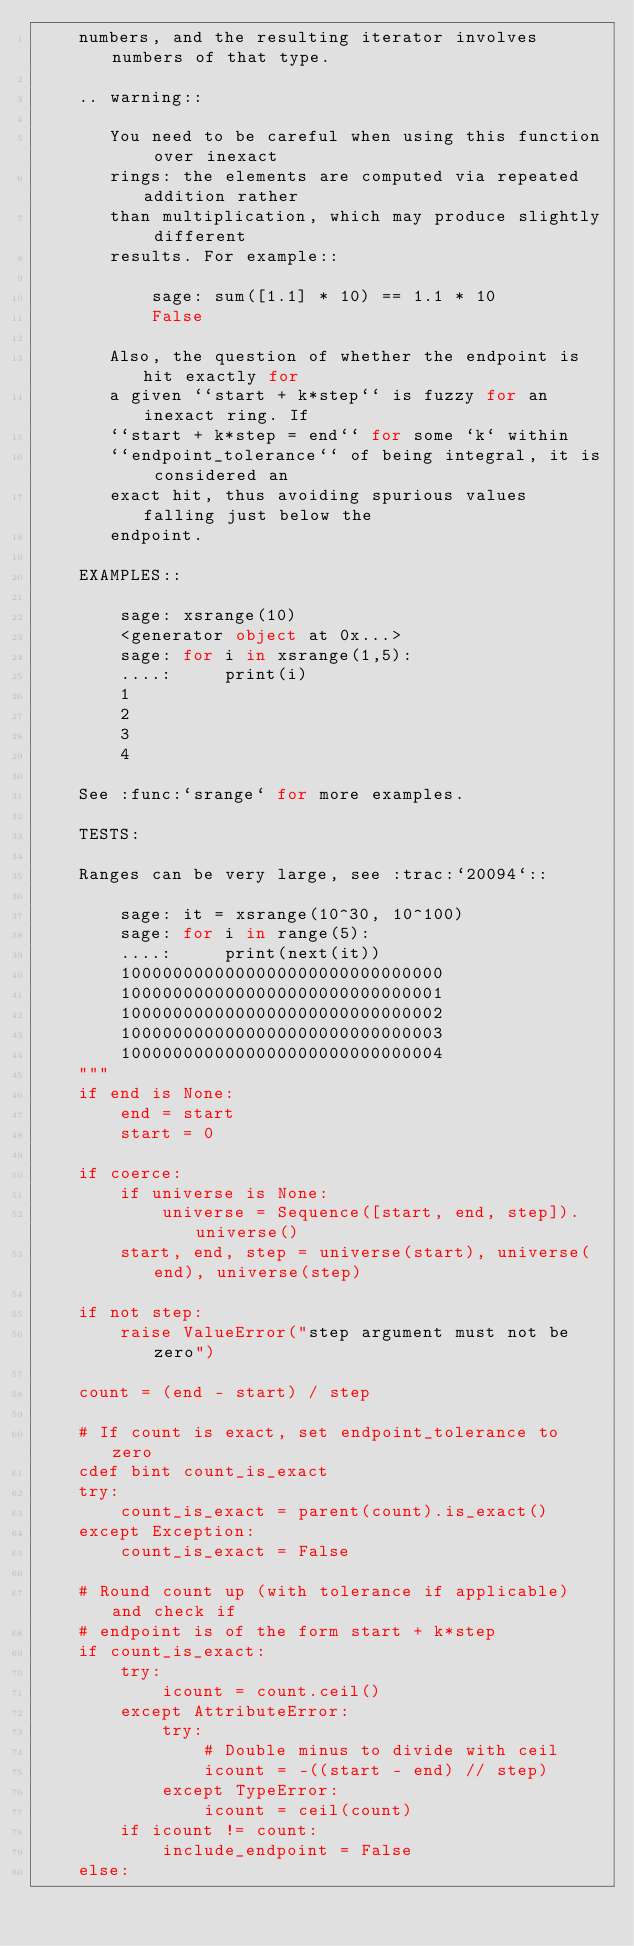<code> <loc_0><loc_0><loc_500><loc_500><_Cython_>    numbers, and the resulting iterator involves numbers of that type.

    .. warning::

       You need to be careful when using this function over inexact
       rings: the elements are computed via repeated addition rather
       than multiplication, which may produce slightly different
       results. For example::

           sage: sum([1.1] * 10) == 1.1 * 10
           False

       Also, the question of whether the endpoint is hit exactly for
       a given ``start + k*step`` is fuzzy for an inexact ring. If
       ``start + k*step = end`` for some `k` within
       ``endpoint_tolerance`` of being integral, it is considered an
       exact hit, thus avoiding spurious values falling just below the
       endpoint.

    EXAMPLES::

        sage: xsrange(10)
        <generator object at 0x...>
        sage: for i in xsrange(1,5):
        ....:     print(i)
        1
        2
        3
        4

    See :func:`srange` for more examples.

    TESTS:

    Ranges can be very large, see :trac:`20094`::

        sage: it = xsrange(10^30, 10^100)
        sage: for i in range(5):
        ....:     print(next(it))
        1000000000000000000000000000000
        1000000000000000000000000000001
        1000000000000000000000000000002
        1000000000000000000000000000003
        1000000000000000000000000000004
    """
    if end is None:
        end = start
        start = 0

    if coerce:
        if universe is None:
            universe = Sequence([start, end, step]).universe()
        start, end, step = universe(start), universe(end), universe(step)

    if not step:
        raise ValueError("step argument must not be zero")

    count = (end - start) / step

    # If count is exact, set endpoint_tolerance to zero
    cdef bint count_is_exact
    try:
        count_is_exact = parent(count).is_exact()
    except Exception:
        count_is_exact = False

    # Round count up (with tolerance if applicable) and check if
    # endpoint is of the form start + k*step
    if count_is_exact:
        try:
            icount = count.ceil()
        except AttributeError:
            try:
                # Double minus to divide with ceil
                icount = -((start - end) // step)
            except TypeError:
                icount = ceil(count)
        if icount != count:
            include_endpoint = False
    else:</code> 